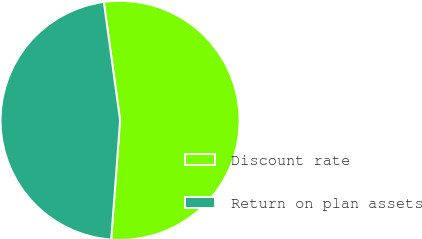Convert chart. <chart><loc_0><loc_0><loc_500><loc_500><pie_chart><fcel>Discount rate<fcel>Return on plan assets<nl><fcel>53.37%<fcel>46.63%<nl></chart> 